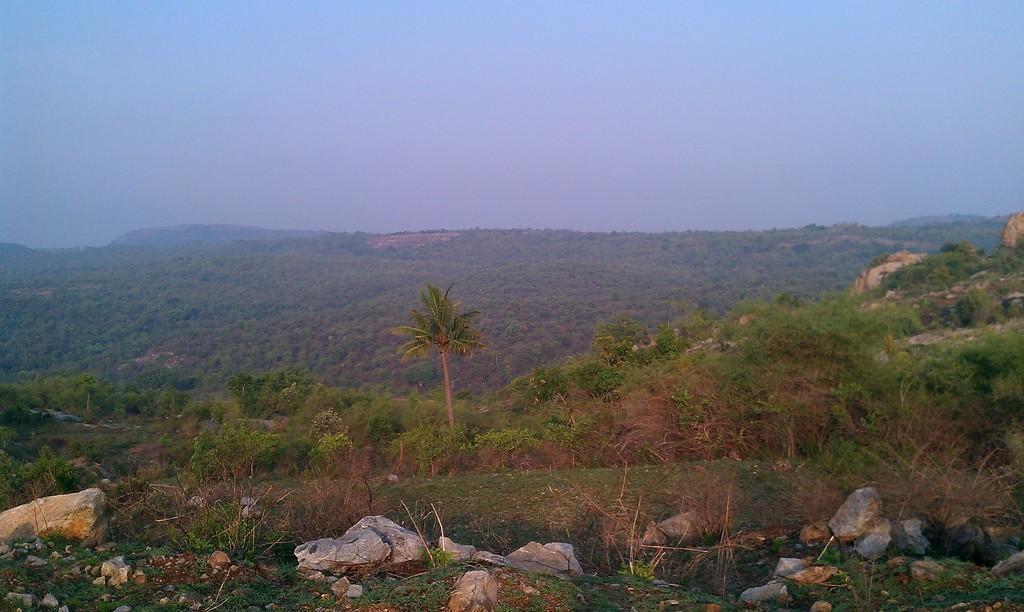In one or two sentences, can you explain what this image depicts? In the picture I can see trees, rocks and the sky in the background. 